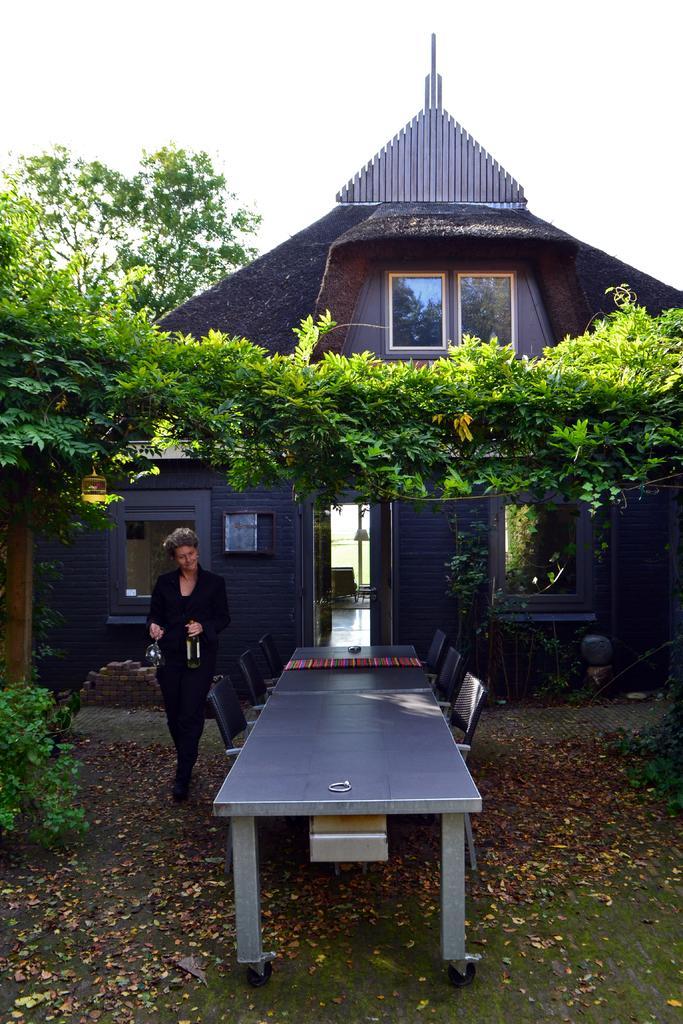Could you give a brief overview of what you see in this image? In this image there is a woman holding glasses and a glass bottle and standing on the ground and on the ground there are dried leaves. Image also consists of a table with chairs. In the background there is a house and also many trees and plants. Sky is also visible. 